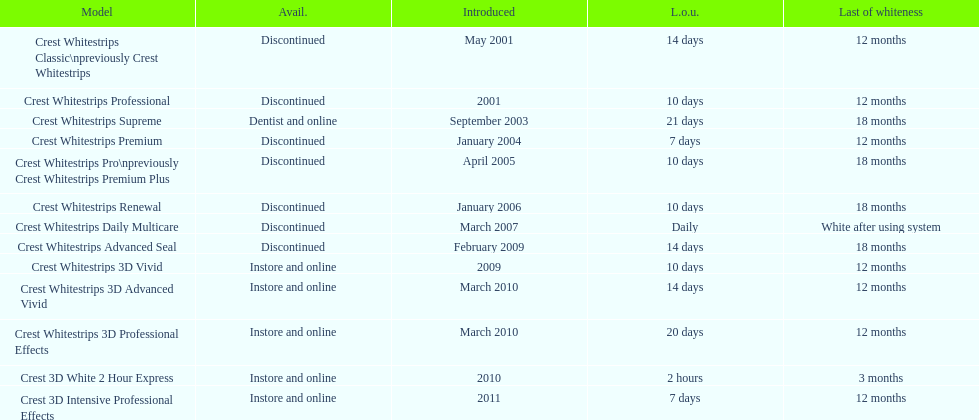What product was introduced in the same month as crest whitestrips 3d advanced vivid? Crest Whitestrips 3D Professional Effects. 